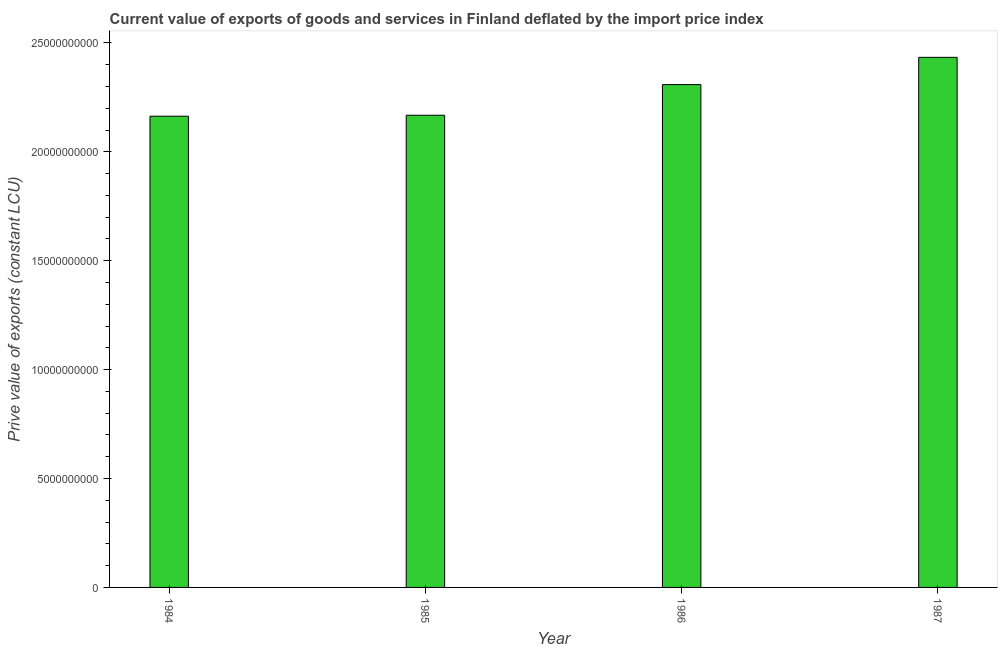What is the title of the graph?
Provide a succinct answer. Current value of exports of goods and services in Finland deflated by the import price index. What is the label or title of the X-axis?
Your response must be concise. Year. What is the label or title of the Y-axis?
Ensure brevity in your answer.  Prive value of exports (constant LCU). What is the price value of exports in 1987?
Offer a very short reply. 2.43e+1. Across all years, what is the maximum price value of exports?
Your answer should be very brief. 2.43e+1. Across all years, what is the minimum price value of exports?
Your answer should be compact. 2.16e+1. What is the sum of the price value of exports?
Provide a succinct answer. 9.07e+1. What is the difference between the price value of exports in 1985 and 1987?
Ensure brevity in your answer.  -2.66e+09. What is the average price value of exports per year?
Make the answer very short. 2.27e+1. What is the median price value of exports?
Make the answer very short. 2.24e+1. In how many years, is the price value of exports greater than 11000000000 LCU?
Your response must be concise. 4. What is the ratio of the price value of exports in 1985 to that in 1987?
Make the answer very short. 0.89. Is the price value of exports in 1985 less than that in 1987?
Ensure brevity in your answer.  Yes. What is the difference between the highest and the second highest price value of exports?
Your answer should be very brief. 1.25e+09. What is the difference between the highest and the lowest price value of exports?
Ensure brevity in your answer.  2.70e+09. In how many years, is the price value of exports greater than the average price value of exports taken over all years?
Your answer should be very brief. 2. How many bars are there?
Give a very brief answer. 4. What is the Prive value of exports (constant LCU) of 1984?
Give a very brief answer. 2.16e+1. What is the Prive value of exports (constant LCU) in 1985?
Ensure brevity in your answer.  2.17e+1. What is the Prive value of exports (constant LCU) of 1986?
Offer a very short reply. 2.31e+1. What is the Prive value of exports (constant LCU) of 1987?
Ensure brevity in your answer.  2.43e+1. What is the difference between the Prive value of exports (constant LCU) in 1984 and 1985?
Keep it short and to the point. -4.41e+07. What is the difference between the Prive value of exports (constant LCU) in 1984 and 1986?
Provide a short and direct response. -1.45e+09. What is the difference between the Prive value of exports (constant LCU) in 1984 and 1987?
Your answer should be compact. -2.70e+09. What is the difference between the Prive value of exports (constant LCU) in 1985 and 1986?
Provide a short and direct response. -1.41e+09. What is the difference between the Prive value of exports (constant LCU) in 1985 and 1987?
Keep it short and to the point. -2.66e+09. What is the difference between the Prive value of exports (constant LCU) in 1986 and 1987?
Your answer should be compact. -1.25e+09. What is the ratio of the Prive value of exports (constant LCU) in 1984 to that in 1985?
Your response must be concise. 1. What is the ratio of the Prive value of exports (constant LCU) in 1984 to that in 1986?
Provide a succinct answer. 0.94. What is the ratio of the Prive value of exports (constant LCU) in 1984 to that in 1987?
Provide a short and direct response. 0.89. What is the ratio of the Prive value of exports (constant LCU) in 1985 to that in 1986?
Your answer should be very brief. 0.94. What is the ratio of the Prive value of exports (constant LCU) in 1985 to that in 1987?
Provide a succinct answer. 0.89. What is the ratio of the Prive value of exports (constant LCU) in 1986 to that in 1987?
Provide a short and direct response. 0.95. 